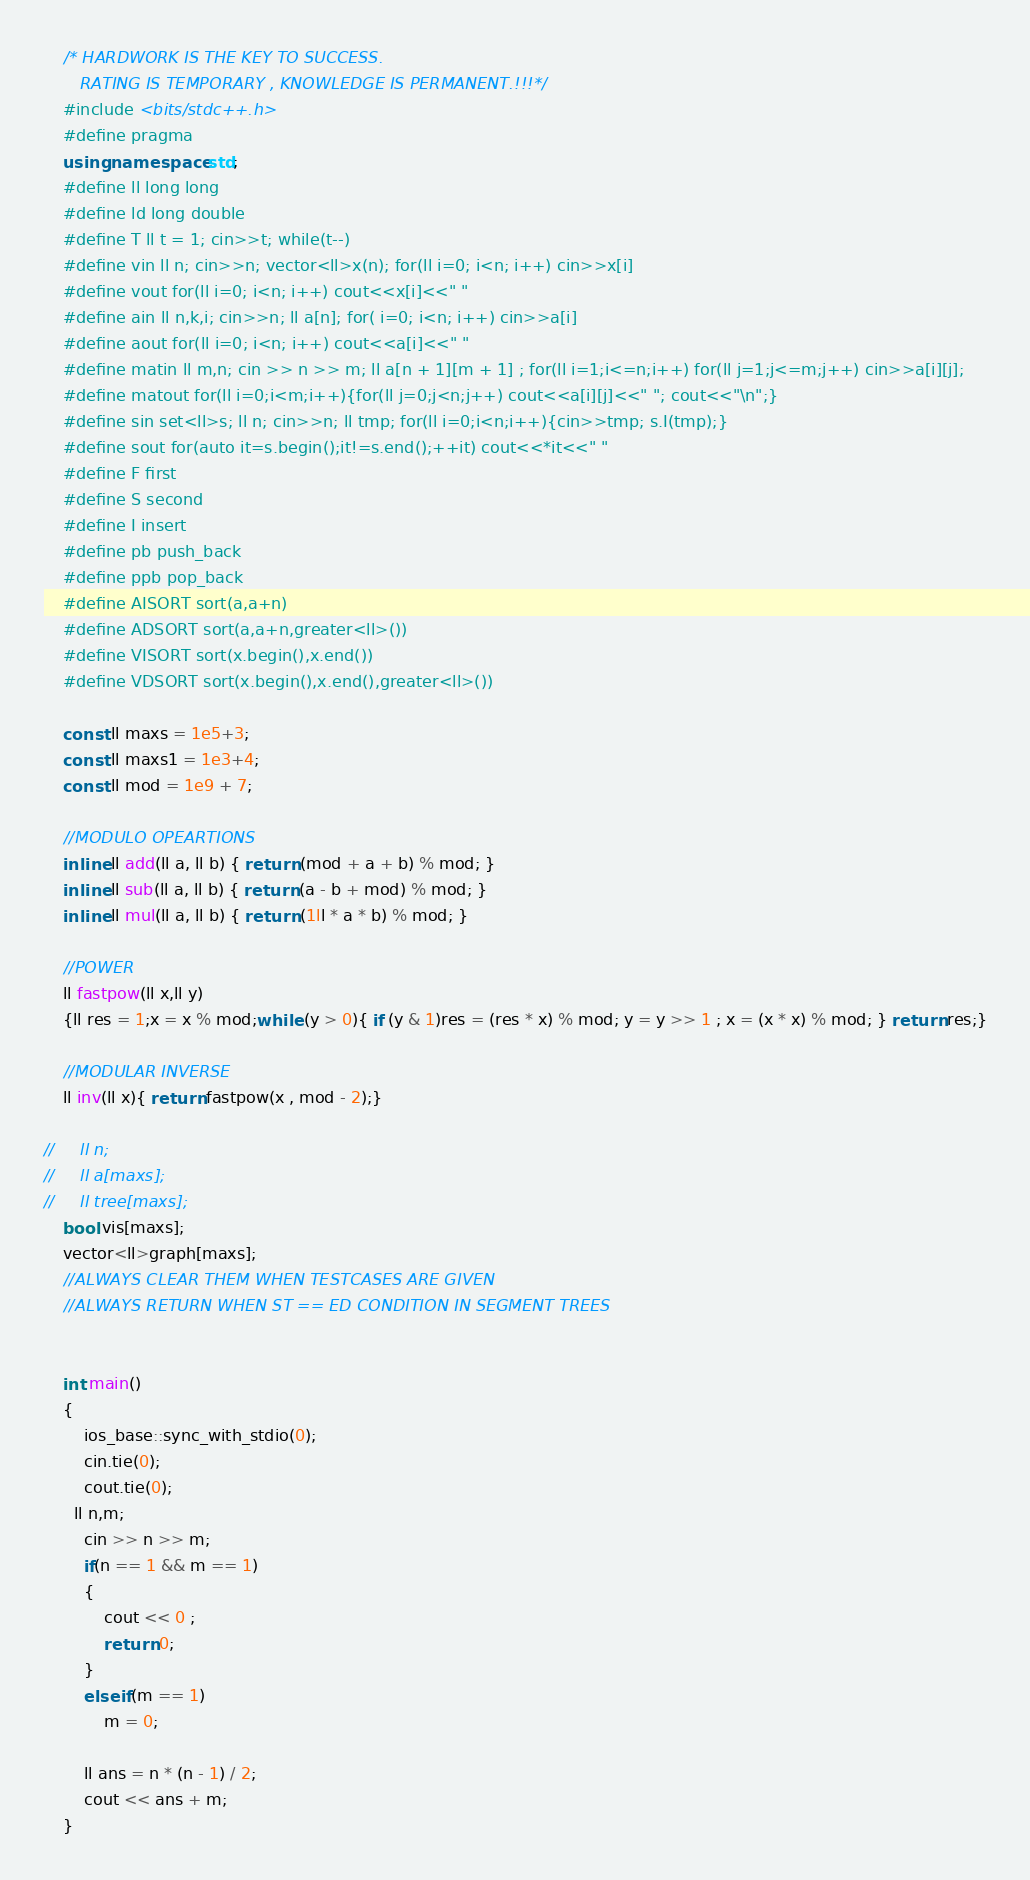Convert code to text. <code><loc_0><loc_0><loc_500><loc_500><_C++_>    /* HARDWORK IS THE KEY TO SUCCESS.
       RATING IS TEMPORARY , KNOWLEDGE IS PERMANENT.!!!*/
    #include <bits/stdc++.h>
    #define pragma
    using namespace std;
    #define ll long long
    #define ld long double
    #define T ll t = 1; cin>>t; while(t--)
    #define vin ll n; cin>>n; vector<ll>x(n); for(ll i=0; i<n; i++) cin>>x[i]
    #define vout for(ll i=0; i<n; i++) cout<<x[i]<<" "
    #define ain ll n,k,i; cin>>n; ll a[n]; for( i=0; i<n; i++) cin>>a[i]
    #define aout for(ll i=0; i<n; i++) cout<<a[i]<<" "
    #define matin ll m,n; cin >> n >> m; ll a[n + 1][m + 1] ; for(ll i=1;i<=n;i++) for(ll j=1;j<=m;j++) cin>>a[i][j];
    #define matout for(ll i=0;i<m;i++){for(ll j=0;j<n;j++) cout<<a[i][j]<<" "; cout<<"\n";}
    #define sin set<ll>s; ll n; cin>>n; ll tmp; for(ll i=0;i<n;i++){cin>>tmp; s.I(tmp);}
    #define sout for(auto it=s.begin();it!=s.end();++it) cout<<*it<<" "
    #define F first
    #define S second
    #define I insert
    #define pb push_back
    #define ppb pop_back
    #define AISORT sort(a,a+n)
    #define ADSORT sort(a,a+n,greater<ll>())
    #define VISORT sort(x.begin(),x.end())
    #define VDSORT sort(x.begin(),x.end(),greater<ll>())

    const ll maxs = 1e5+3;
    const ll maxs1 = 1e3+4;
    const ll mod = 1e9 + 7;

    //MODULO OPEARTIONS
    inline ll add(ll a, ll b) { return (mod + a + b) % mod; }
    inline ll sub(ll a, ll b) { return (a - b + mod) % mod; }
    inline ll mul(ll a, ll b) { return (1ll * a * b) % mod; }

    //POWER
    ll fastpow(ll x,ll y)
    {ll res = 1;x = x % mod;while (y > 0){ if (y & 1)res = (res * x) % mod; y = y >> 1 ; x = (x * x) % mod; } return res;}

    //MODULAR INVERSE
    ll inv(ll x){ return fastpow(x , mod - 2);}

//     ll n;
//     ll a[maxs];
//     ll tree[maxs];
    bool vis[maxs];
    vector<ll>graph[maxs];
    //ALWAYS CLEAR THEM WHEN TESTCASES ARE GIVEN
    //ALWAYS RETURN WHEN ST == ED CONDITION IN SEGMENT TREES


    int main()
    {
        ios_base::sync_with_stdio(0);
        cin.tie(0);
        cout.tie(0);
      ll n,m;
        cin >> n >> m;
        if(n == 1 && m == 1)
        {
            cout << 0 ;
            return 0;
        }
        else if(m == 1)
            m = 0;
            
        ll ans = n * (n - 1) / 2;
        cout << ans + m;
    }
</code> 